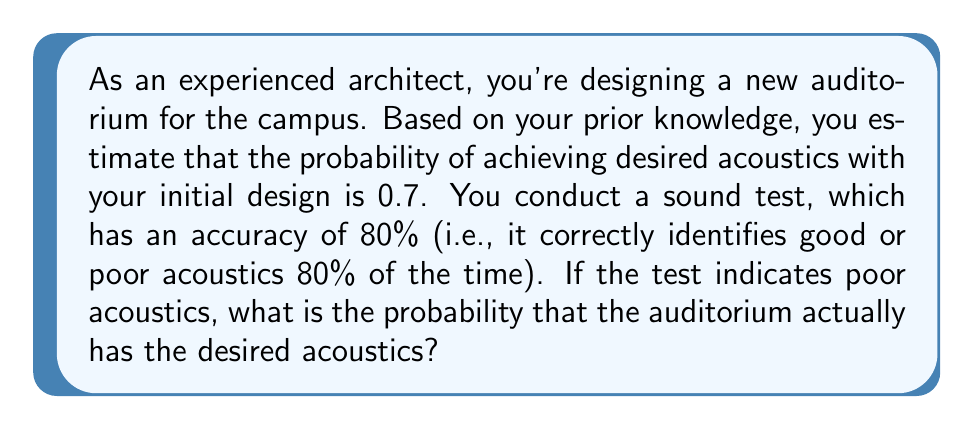Can you answer this question? Let's approach this problem using Bayesian inference:

1) Define our events:
   A: The auditorium has desired acoustics
   T: The test indicates poor acoustics

2) Given information:
   P(A) = 0.7 (prior probability)
   P(T|A) = 0.2 (probability of test indicating poor acoustics when acoustics are actually good)
   P(T|not A) = 0.8 (probability of test indicating poor acoustics when acoustics are actually poor)

3) We want to find P(A|T) using Bayes' theorem:

   $$P(A|T) = \frac{P(T|A) \cdot P(A)}{P(T)}$$

4) Calculate P(T) using the law of total probability:
   
   $$P(T) = P(T|A) \cdot P(A) + P(T|not A) \cdot P(not A)$$
   $$P(T) = 0.2 \cdot 0.7 + 0.8 \cdot 0.3 = 0.14 + 0.24 = 0.38$$

5) Now we can apply Bayes' theorem:

   $$P(A|T) = \frac{0.2 \cdot 0.7}{0.38} = \frac{0.14}{0.38} \approx 0.3684$$

6) Convert to a percentage:
   0.3684 * 100% ≈ 36.84%
Answer: 36.84% 